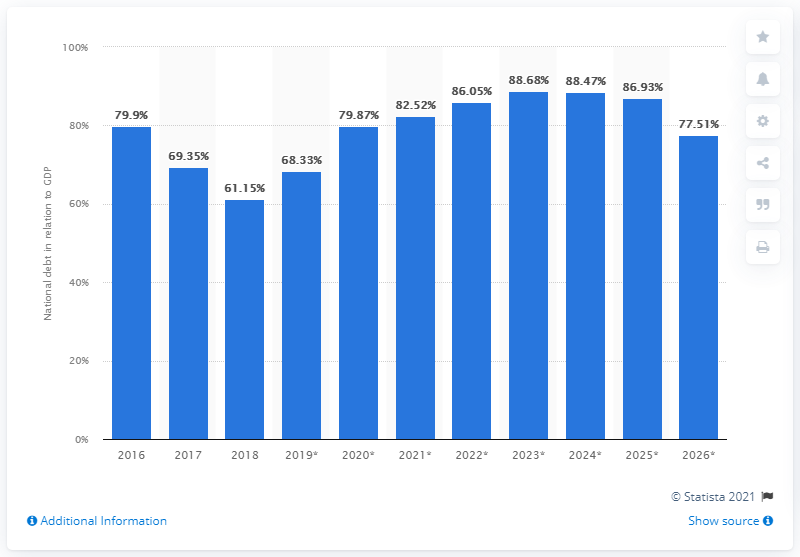List a handful of essential elements in this visual. In 2018, the national debt of Iceland accounted for 61.15% of the country's Gross Domestic Product (GDP). 